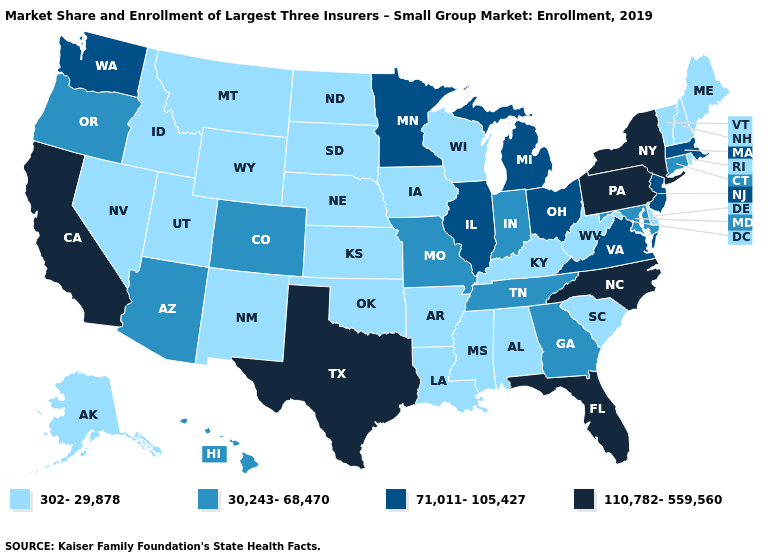Does Colorado have the lowest value in the West?
Keep it brief. No. Does Alaska have a lower value than Iowa?
Keep it brief. No. Among the states that border Idaho , does Nevada have the highest value?
Keep it brief. No. Does New Jersey have the same value as Nevada?
Keep it brief. No. Does the first symbol in the legend represent the smallest category?
Give a very brief answer. Yes. Name the states that have a value in the range 110,782-559,560?
Quick response, please. California, Florida, New York, North Carolina, Pennsylvania, Texas. What is the lowest value in states that border Georgia?
Write a very short answer. 302-29,878. Does Delaware have the highest value in the South?
Write a very short answer. No. What is the highest value in states that border Ohio?
Answer briefly. 110,782-559,560. What is the highest value in states that border Idaho?
Give a very brief answer. 71,011-105,427. What is the value of Montana?
Concise answer only. 302-29,878. Does Nebraska have the lowest value in the USA?
Give a very brief answer. Yes. What is the highest value in states that border Minnesota?
Give a very brief answer. 302-29,878. What is the lowest value in the Northeast?
Write a very short answer. 302-29,878. 